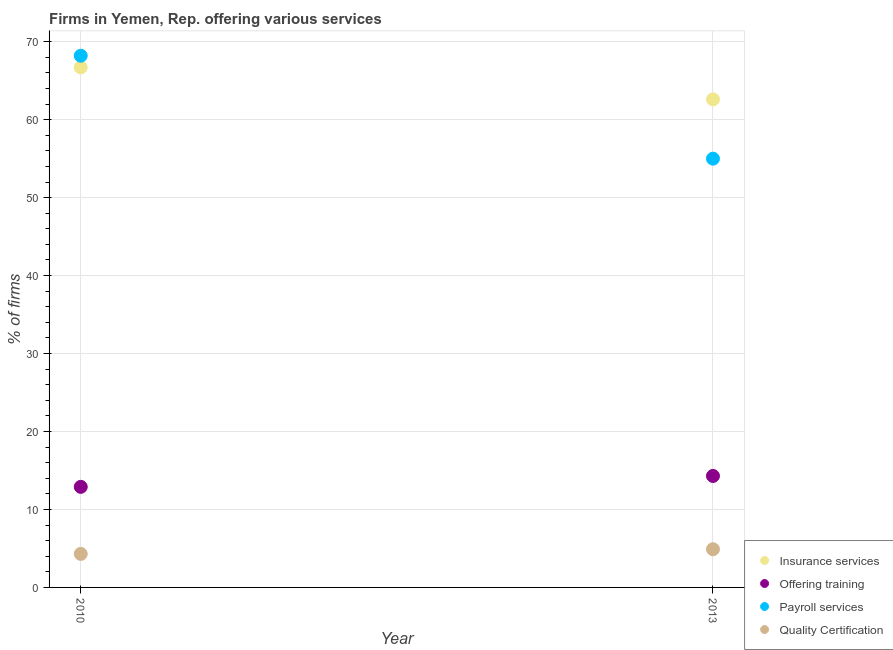How many different coloured dotlines are there?
Your response must be concise. 4. Is the number of dotlines equal to the number of legend labels?
Your answer should be very brief. Yes. What is the percentage of firms offering payroll services in 2013?
Give a very brief answer. 55. Across all years, what is the minimum percentage of firms offering insurance services?
Ensure brevity in your answer.  62.6. In which year was the percentage of firms offering quality certification minimum?
Make the answer very short. 2010. What is the total percentage of firms offering insurance services in the graph?
Ensure brevity in your answer.  129.3. What is the difference between the percentage of firms offering insurance services in 2010 and that in 2013?
Your answer should be very brief. 4.1. What is the difference between the percentage of firms offering quality certification in 2010 and the percentage of firms offering payroll services in 2013?
Give a very brief answer. -50.7. What is the average percentage of firms offering payroll services per year?
Your response must be concise. 61.6. In how many years, is the percentage of firms offering payroll services greater than 20 %?
Provide a succinct answer. 2. What is the ratio of the percentage of firms offering quality certification in 2010 to that in 2013?
Provide a short and direct response. 0.88. In how many years, is the percentage of firms offering training greater than the average percentage of firms offering training taken over all years?
Keep it short and to the point. 1. Is it the case that in every year, the sum of the percentage of firms offering quality certification and percentage of firms offering insurance services is greater than the sum of percentage of firms offering training and percentage of firms offering payroll services?
Make the answer very short. Yes. Is it the case that in every year, the sum of the percentage of firms offering insurance services and percentage of firms offering training is greater than the percentage of firms offering payroll services?
Your response must be concise. Yes. Does the percentage of firms offering payroll services monotonically increase over the years?
Your response must be concise. No. How many years are there in the graph?
Keep it short and to the point. 2. Are the values on the major ticks of Y-axis written in scientific E-notation?
Your answer should be very brief. No. Does the graph contain grids?
Give a very brief answer. Yes. How many legend labels are there?
Make the answer very short. 4. What is the title of the graph?
Your response must be concise. Firms in Yemen, Rep. offering various services . What is the label or title of the X-axis?
Your answer should be very brief. Year. What is the label or title of the Y-axis?
Offer a very short reply. % of firms. What is the % of firms in Insurance services in 2010?
Make the answer very short. 66.7. What is the % of firms of Payroll services in 2010?
Ensure brevity in your answer.  68.2. What is the % of firms in Insurance services in 2013?
Provide a succinct answer. 62.6. Across all years, what is the maximum % of firms of Insurance services?
Offer a terse response. 66.7. Across all years, what is the maximum % of firms in Offering training?
Offer a very short reply. 14.3. Across all years, what is the maximum % of firms of Payroll services?
Provide a succinct answer. 68.2. Across all years, what is the maximum % of firms of Quality Certification?
Ensure brevity in your answer.  4.9. Across all years, what is the minimum % of firms in Insurance services?
Provide a succinct answer. 62.6. What is the total % of firms of Insurance services in the graph?
Provide a short and direct response. 129.3. What is the total % of firms of Offering training in the graph?
Your answer should be very brief. 27.2. What is the total % of firms in Payroll services in the graph?
Offer a very short reply. 123.2. What is the difference between the % of firms of Insurance services in 2010 and that in 2013?
Your answer should be compact. 4.1. What is the difference between the % of firms in Quality Certification in 2010 and that in 2013?
Provide a short and direct response. -0.6. What is the difference between the % of firms of Insurance services in 2010 and the % of firms of Offering training in 2013?
Provide a succinct answer. 52.4. What is the difference between the % of firms in Insurance services in 2010 and the % of firms in Quality Certification in 2013?
Make the answer very short. 61.8. What is the difference between the % of firms of Offering training in 2010 and the % of firms of Payroll services in 2013?
Give a very brief answer. -42.1. What is the difference between the % of firms in Payroll services in 2010 and the % of firms in Quality Certification in 2013?
Your response must be concise. 63.3. What is the average % of firms of Insurance services per year?
Give a very brief answer. 64.65. What is the average % of firms in Payroll services per year?
Your answer should be compact. 61.6. In the year 2010, what is the difference between the % of firms of Insurance services and % of firms of Offering training?
Give a very brief answer. 53.8. In the year 2010, what is the difference between the % of firms in Insurance services and % of firms in Payroll services?
Offer a very short reply. -1.5. In the year 2010, what is the difference between the % of firms of Insurance services and % of firms of Quality Certification?
Give a very brief answer. 62.4. In the year 2010, what is the difference between the % of firms of Offering training and % of firms of Payroll services?
Your answer should be compact. -55.3. In the year 2010, what is the difference between the % of firms of Payroll services and % of firms of Quality Certification?
Provide a succinct answer. 63.9. In the year 2013, what is the difference between the % of firms of Insurance services and % of firms of Offering training?
Your response must be concise. 48.3. In the year 2013, what is the difference between the % of firms in Insurance services and % of firms in Quality Certification?
Your answer should be very brief. 57.7. In the year 2013, what is the difference between the % of firms in Offering training and % of firms in Payroll services?
Your answer should be very brief. -40.7. In the year 2013, what is the difference between the % of firms in Offering training and % of firms in Quality Certification?
Your answer should be compact. 9.4. In the year 2013, what is the difference between the % of firms in Payroll services and % of firms in Quality Certification?
Ensure brevity in your answer.  50.1. What is the ratio of the % of firms in Insurance services in 2010 to that in 2013?
Your answer should be compact. 1.07. What is the ratio of the % of firms of Offering training in 2010 to that in 2013?
Keep it short and to the point. 0.9. What is the ratio of the % of firms of Payroll services in 2010 to that in 2013?
Your answer should be very brief. 1.24. What is the ratio of the % of firms of Quality Certification in 2010 to that in 2013?
Provide a short and direct response. 0.88. What is the difference between the highest and the second highest % of firms in Payroll services?
Your answer should be compact. 13.2. What is the difference between the highest and the lowest % of firms in Offering training?
Your response must be concise. 1.4. What is the difference between the highest and the lowest % of firms of Quality Certification?
Provide a short and direct response. 0.6. 